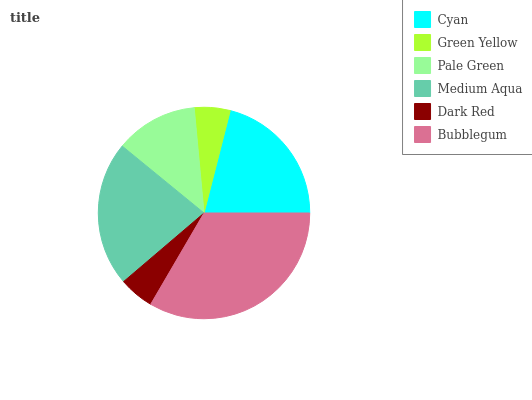Is Dark Red the minimum?
Answer yes or no. Yes. Is Bubblegum the maximum?
Answer yes or no. Yes. Is Green Yellow the minimum?
Answer yes or no. No. Is Green Yellow the maximum?
Answer yes or no. No. Is Cyan greater than Green Yellow?
Answer yes or no. Yes. Is Green Yellow less than Cyan?
Answer yes or no. Yes. Is Green Yellow greater than Cyan?
Answer yes or no. No. Is Cyan less than Green Yellow?
Answer yes or no. No. Is Cyan the high median?
Answer yes or no. Yes. Is Pale Green the low median?
Answer yes or no. Yes. Is Pale Green the high median?
Answer yes or no. No. Is Dark Red the low median?
Answer yes or no. No. 